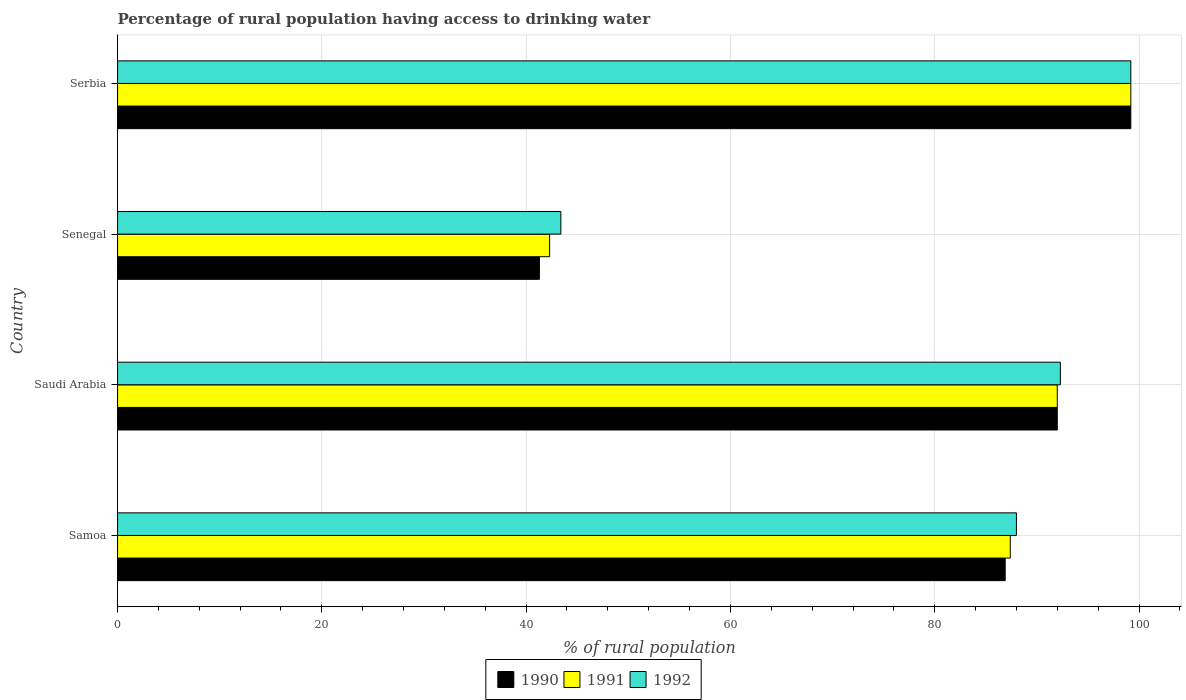How many bars are there on the 4th tick from the top?
Give a very brief answer. 3. What is the label of the 1st group of bars from the top?
Your answer should be very brief. Serbia. What is the percentage of rural population having access to drinking water in 1992 in Serbia?
Give a very brief answer. 99.2. Across all countries, what is the maximum percentage of rural population having access to drinking water in 1992?
Give a very brief answer. 99.2. Across all countries, what is the minimum percentage of rural population having access to drinking water in 1992?
Provide a succinct answer. 43.4. In which country was the percentage of rural population having access to drinking water in 1990 maximum?
Offer a very short reply. Serbia. In which country was the percentage of rural population having access to drinking water in 1990 minimum?
Your answer should be compact. Senegal. What is the total percentage of rural population having access to drinking water in 1991 in the graph?
Make the answer very short. 320.9. What is the difference between the percentage of rural population having access to drinking water in 1991 in Samoa and that in Serbia?
Your answer should be very brief. -11.8. What is the difference between the percentage of rural population having access to drinking water in 1992 in Serbia and the percentage of rural population having access to drinking water in 1991 in Senegal?
Your response must be concise. 56.9. What is the average percentage of rural population having access to drinking water in 1991 per country?
Your answer should be very brief. 80.22. What is the difference between the percentage of rural population having access to drinking water in 1991 and percentage of rural population having access to drinking water in 1990 in Senegal?
Keep it short and to the point. 1. What is the ratio of the percentage of rural population having access to drinking water in 1991 in Senegal to that in Serbia?
Your answer should be very brief. 0.43. What is the difference between the highest and the second highest percentage of rural population having access to drinking water in 1990?
Offer a very short reply. 7.2. What is the difference between the highest and the lowest percentage of rural population having access to drinking water in 1992?
Your answer should be very brief. 55.8. In how many countries, is the percentage of rural population having access to drinking water in 1990 greater than the average percentage of rural population having access to drinking water in 1990 taken over all countries?
Your answer should be very brief. 3. Is it the case that in every country, the sum of the percentage of rural population having access to drinking water in 1991 and percentage of rural population having access to drinking water in 1990 is greater than the percentage of rural population having access to drinking water in 1992?
Provide a short and direct response. Yes. How many bars are there?
Your answer should be compact. 12. Are all the bars in the graph horizontal?
Offer a very short reply. Yes. What is the difference between two consecutive major ticks on the X-axis?
Your response must be concise. 20. Does the graph contain grids?
Make the answer very short. Yes. Where does the legend appear in the graph?
Provide a short and direct response. Bottom center. How many legend labels are there?
Provide a short and direct response. 3. What is the title of the graph?
Keep it short and to the point. Percentage of rural population having access to drinking water. Does "1985" appear as one of the legend labels in the graph?
Offer a terse response. No. What is the label or title of the X-axis?
Your answer should be very brief. % of rural population. What is the % of rural population in 1990 in Samoa?
Provide a succinct answer. 86.9. What is the % of rural population in 1991 in Samoa?
Your answer should be very brief. 87.4. What is the % of rural population of 1992 in Samoa?
Ensure brevity in your answer.  88. What is the % of rural population of 1990 in Saudi Arabia?
Provide a short and direct response. 92. What is the % of rural population in 1991 in Saudi Arabia?
Make the answer very short. 92. What is the % of rural population of 1992 in Saudi Arabia?
Ensure brevity in your answer.  92.3. What is the % of rural population in 1990 in Senegal?
Give a very brief answer. 41.3. What is the % of rural population of 1991 in Senegal?
Keep it short and to the point. 42.3. What is the % of rural population in 1992 in Senegal?
Your answer should be very brief. 43.4. What is the % of rural population of 1990 in Serbia?
Offer a terse response. 99.2. What is the % of rural population in 1991 in Serbia?
Ensure brevity in your answer.  99.2. What is the % of rural population of 1992 in Serbia?
Provide a succinct answer. 99.2. Across all countries, what is the maximum % of rural population of 1990?
Your response must be concise. 99.2. Across all countries, what is the maximum % of rural population of 1991?
Offer a very short reply. 99.2. Across all countries, what is the maximum % of rural population in 1992?
Offer a very short reply. 99.2. Across all countries, what is the minimum % of rural population of 1990?
Provide a succinct answer. 41.3. Across all countries, what is the minimum % of rural population of 1991?
Your answer should be very brief. 42.3. Across all countries, what is the minimum % of rural population of 1992?
Offer a terse response. 43.4. What is the total % of rural population of 1990 in the graph?
Provide a succinct answer. 319.4. What is the total % of rural population of 1991 in the graph?
Your response must be concise. 320.9. What is the total % of rural population in 1992 in the graph?
Provide a short and direct response. 322.9. What is the difference between the % of rural population of 1991 in Samoa and that in Saudi Arabia?
Offer a terse response. -4.6. What is the difference between the % of rural population of 1992 in Samoa and that in Saudi Arabia?
Provide a short and direct response. -4.3. What is the difference between the % of rural population of 1990 in Samoa and that in Senegal?
Provide a succinct answer. 45.6. What is the difference between the % of rural population of 1991 in Samoa and that in Senegal?
Offer a terse response. 45.1. What is the difference between the % of rural population of 1992 in Samoa and that in Senegal?
Keep it short and to the point. 44.6. What is the difference between the % of rural population in 1990 in Samoa and that in Serbia?
Offer a terse response. -12.3. What is the difference between the % of rural population of 1991 in Samoa and that in Serbia?
Provide a short and direct response. -11.8. What is the difference between the % of rural population of 1992 in Samoa and that in Serbia?
Give a very brief answer. -11.2. What is the difference between the % of rural population of 1990 in Saudi Arabia and that in Senegal?
Offer a terse response. 50.7. What is the difference between the % of rural population of 1991 in Saudi Arabia and that in Senegal?
Your answer should be very brief. 49.7. What is the difference between the % of rural population of 1992 in Saudi Arabia and that in Senegal?
Your answer should be compact. 48.9. What is the difference between the % of rural population in 1990 in Saudi Arabia and that in Serbia?
Your answer should be compact. -7.2. What is the difference between the % of rural population in 1991 in Saudi Arabia and that in Serbia?
Your answer should be compact. -7.2. What is the difference between the % of rural population in 1990 in Senegal and that in Serbia?
Provide a short and direct response. -57.9. What is the difference between the % of rural population of 1991 in Senegal and that in Serbia?
Provide a short and direct response. -56.9. What is the difference between the % of rural population of 1992 in Senegal and that in Serbia?
Give a very brief answer. -55.8. What is the difference between the % of rural population of 1990 in Samoa and the % of rural population of 1991 in Saudi Arabia?
Ensure brevity in your answer.  -5.1. What is the difference between the % of rural population of 1990 in Samoa and the % of rural population of 1991 in Senegal?
Offer a terse response. 44.6. What is the difference between the % of rural population in 1990 in Samoa and the % of rural population in 1992 in Senegal?
Provide a short and direct response. 43.5. What is the difference between the % of rural population of 1991 in Samoa and the % of rural population of 1992 in Senegal?
Provide a succinct answer. 44. What is the difference between the % of rural population in 1990 in Samoa and the % of rural population in 1991 in Serbia?
Your answer should be compact. -12.3. What is the difference between the % of rural population in 1990 in Samoa and the % of rural population in 1992 in Serbia?
Provide a short and direct response. -12.3. What is the difference between the % of rural population in 1991 in Samoa and the % of rural population in 1992 in Serbia?
Your answer should be very brief. -11.8. What is the difference between the % of rural population of 1990 in Saudi Arabia and the % of rural population of 1991 in Senegal?
Make the answer very short. 49.7. What is the difference between the % of rural population of 1990 in Saudi Arabia and the % of rural population of 1992 in Senegal?
Your answer should be very brief. 48.6. What is the difference between the % of rural population in 1991 in Saudi Arabia and the % of rural population in 1992 in Senegal?
Ensure brevity in your answer.  48.6. What is the difference between the % of rural population of 1990 in Senegal and the % of rural population of 1991 in Serbia?
Ensure brevity in your answer.  -57.9. What is the difference between the % of rural population in 1990 in Senegal and the % of rural population in 1992 in Serbia?
Give a very brief answer. -57.9. What is the difference between the % of rural population of 1991 in Senegal and the % of rural population of 1992 in Serbia?
Provide a short and direct response. -56.9. What is the average % of rural population of 1990 per country?
Your answer should be compact. 79.85. What is the average % of rural population in 1991 per country?
Offer a terse response. 80.22. What is the average % of rural population of 1992 per country?
Your answer should be very brief. 80.72. What is the difference between the % of rural population of 1990 and % of rural population of 1991 in Samoa?
Provide a succinct answer. -0.5. What is the difference between the % of rural population in 1990 and % of rural population in 1992 in Samoa?
Make the answer very short. -1.1. What is the difference between the % of rural population in 1991 and % of rural population in 1992 in Samoa?
Keep it short and to the point. -0.6. What is the difference between the % of rural population in 1990 and % of rural population in 1991 in Senegal?
Your answer should be very brief. -1. What is the difference between the % of rural population in 1990 and % of rural population in 1992 in Senegal?
Keep it short and to the point. -2.1. What is the difference between the % of rural population of 1991 and % of rural population of 1992 in Senegal?
Provide a short and direct response. -1.1. What is the difference between the % of rural population of 1991 and % of rural population of 1992 in Serbia?
Give a very brief answer. 0. What is the ratio of the % of rural population of 1990 in Samoa to that in Saudi Arabia?
Give a very brief answer. 0.94. What is the ratio of the % of rural population of 1992 in Samoa to that in Saudi Arabia?
Offer a very short reply. 0.95. What is the ratio of the % of rural population in 1990 in Samoa to that in Senegal?
Make the answer very short. 2.1. What is the ratio of the % of rural population of 1991 in Samoa to that in Senegal?
Your response must be concise. 2.07. What is the ratio of the % of rural population of 1992 in Samoa to that in Senegal?
Make the answer very short. 2.03. What is the ratio of the % of rural population in 1990 in Samoa to that in Serbia?
Offer a terse response. 0.88. What is the ratio of the % of rural population of 1991 in Samoa to that in Serbia?
Offer a terse response. 0.88. What is the ratio of the % of rural population in 1992 in Samoa to that in Serbia?
Your response must be concise. 0.89. What is the ratio of the % of rural population in 1990 in Saudi Arabia to that in Senegal?
Give a very brief answer. 2.23. What is the ratio of the % of rural population in 1991 in Saudi Arabia to that in Senegal?
Keep it short and to the point. 2.17. What is the ratio of the % of rural population in 1992 in Saudi Arabia to that in Senegal?
Give a very brief answer. 2.13. What is the ratio of the % of rural population in 1990 in Saudi Arabia to that in Serbia?
Your answer should be compact. 0.93. What is the ratio of the % of rural population in 1991 in Saudi Arabia to that in Serbia?
Ensure brevity in your answer.  0.93. What is the ratio of the % of rural population in 1992 in Saudi Arabia to that in Serbia?
Provide a short and direct response. 0.93. What is the ratio of the % of rural population of 1990 in Senegal to that in Serbia?
Your answer should be compact. 0.42. What is the ratio of the % of rural population of 1991 in Senegal to that in Serbia?
Your answer should be very brief. 0.43. What is the ratio of the % of rural population of 1992 in Senegal to that in Serbia?
Your answer should be compact. 0.44. What is the difference between the highest and the second highest % of rural population of 1990?
Your answer should be very brief. 7.2. What is the difference between the highest and the second highest % of rural population of 1991?
Ensure brevity in your answer.  7.2. What is the difference between the highest and the second highest % of rural population in 1992?
Offer a very short reply. 6.9. What is the difference between the highest and the lowest % of rural population in 1990?
Keep it short and to the point. 57.9. What is the difference between the highest and the lowest % of rural population in 1991?
Give a very brief answer. 56.9. What is the difference between the highest and the lowest % of rural population of 1992?
Offer a very short reply. 55.8. 